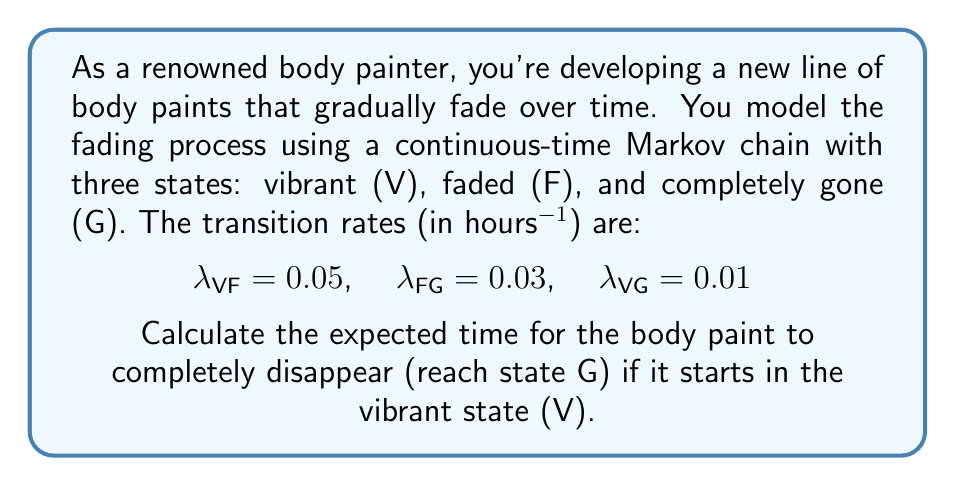Can you answer this question? To solve this problem, we'll use the concept of mean first passage times in continuous-time Markov chains.

Step 1: Define the mean first passage times
Let $m_V$ and $m_F$ be the mean times to reach state G from states V and F, respectively.

Step 2: Set up the system of equations
For state V:
$$m_V = \frac{1}{\lambda_{VF} + \lambda_{VG}} + \frac{\lambda_{VF}}{\lambda_{VF} + \lambda_{VG}}m_F$$

For state F:
$$m_F = \frac{1}{\lambda_{FG}} + 0$$

Step 3: Solve for $m_F$
$$m_F = \frac{1}{\lambda_{FG}} = \frac{1}{0.03} = 33.33 \text{ hours}$$

Step 4: Substitute $m_F$ into the equation for $m_V$
$$m_V = \frac{1}{0.05 + 0.01} + \frac{0.05}{0.05 + 0.01}(33.33)$$

Step 5: Simplify and calculate $m_V$
$$m_V = \frac{1}{0.06} + \frac{5}{6}(33.33)$$
$$m_V = 16.67 + 27.78 = 44.45 \text{ hours}$$

Therefore, the expected time for the body paint to completely disappear, starting from the vibrant state, is approximately 44.45 hours.
Answer: 44.45 hours 